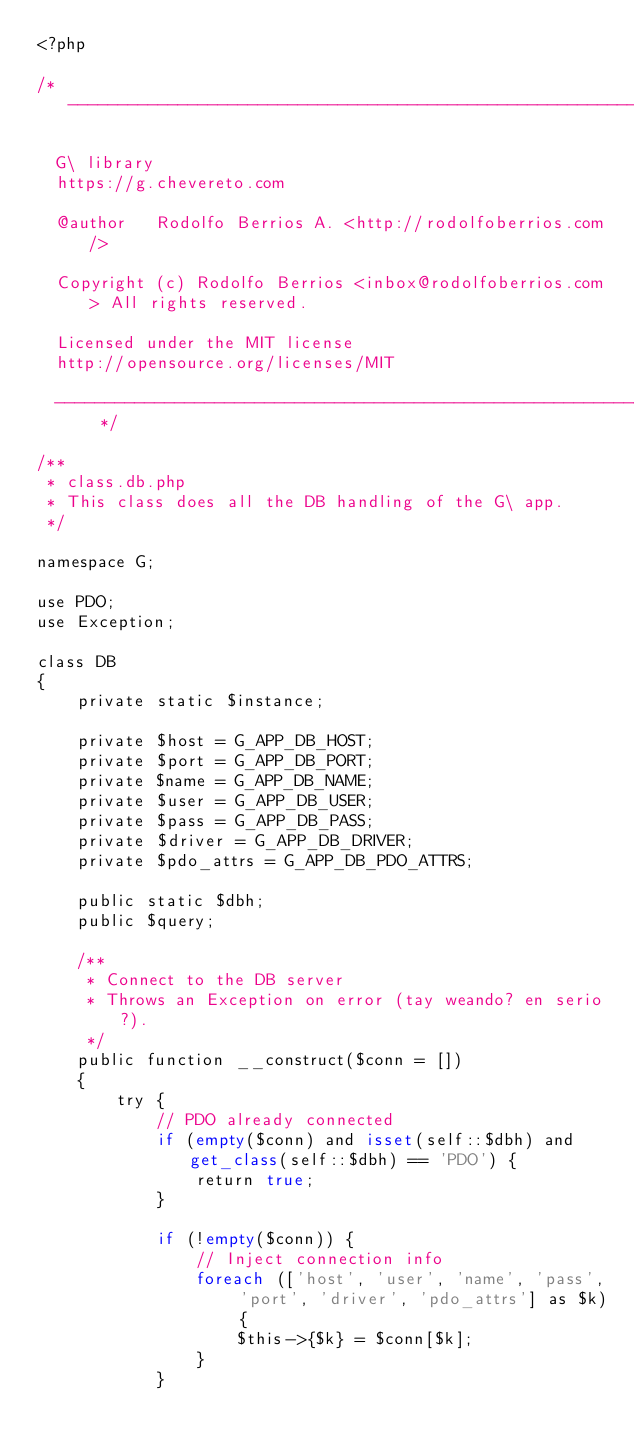<code> <loc_0><loc_0><loc_500><loc_500><_PHP_><?php

/* --------------------------------------------------------------------

  G\ library
  https://g.chevereto.com

  @author	Rodolfo Berrios A. <http://rodolfoberrios.com/>

  Copyright (c) Rodolfo Berrios <inbox@rodolfoberrios.com> All rights reserved.

  Licensed under the MIT license
  http://opensource.org/licenses/MIT

  --------------------------------------------------------------------- */

/**
 * class.db.php
 * This class does all the DB handling of the G\ app.
 */

namespace G;

use PDO;
use Exception;

class DB
{
    private static $instance;

    private $host = G_APP_DB_HOST;
    private $port = G_APP_DB_PORT;
    private $name = G_APP_DB_NAME;
    private $user = G_APP_DB_USER;
    private $pass = G_APP_DB_PASS;
    private $driver = G_APP_DB_DRIVER;
    private $pdo_attrs = G_APP_DB_PDO_ATTRS;

    public static $dbh;
    public $query;

    /**
     * Connect to the DB server
     * Throws an Exception on error (tay weando? en serio?).
     */
    public function __construct($conn = [])
    {
        try {
            // PDO already connected
            if (empty($conn) and isset(self::$dbh) and get_class(self::$dbh) == 'PDO') {
                return true;
            }

            if (!empty($conn)) {
                // Inject connection info
                foreach (['host', 'user', 'name', 'pass', 'port', 'driver', 'pdo_attrs'] as $k) {
                    $this->{$k} = $conn[$k];
                }
            }
</code> 